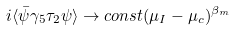Convert formula to latex. <formula><loc_0><loc_0><loc_500><loc_500>i \langle \bar { \psi } \gamma _ { 5 } \tau _ { 2 } \psi \rangle \rightarrow c o n s t ( \mu _ { I } - \mu _ { c } ) ^ { \beta _ { m } }</formula> 